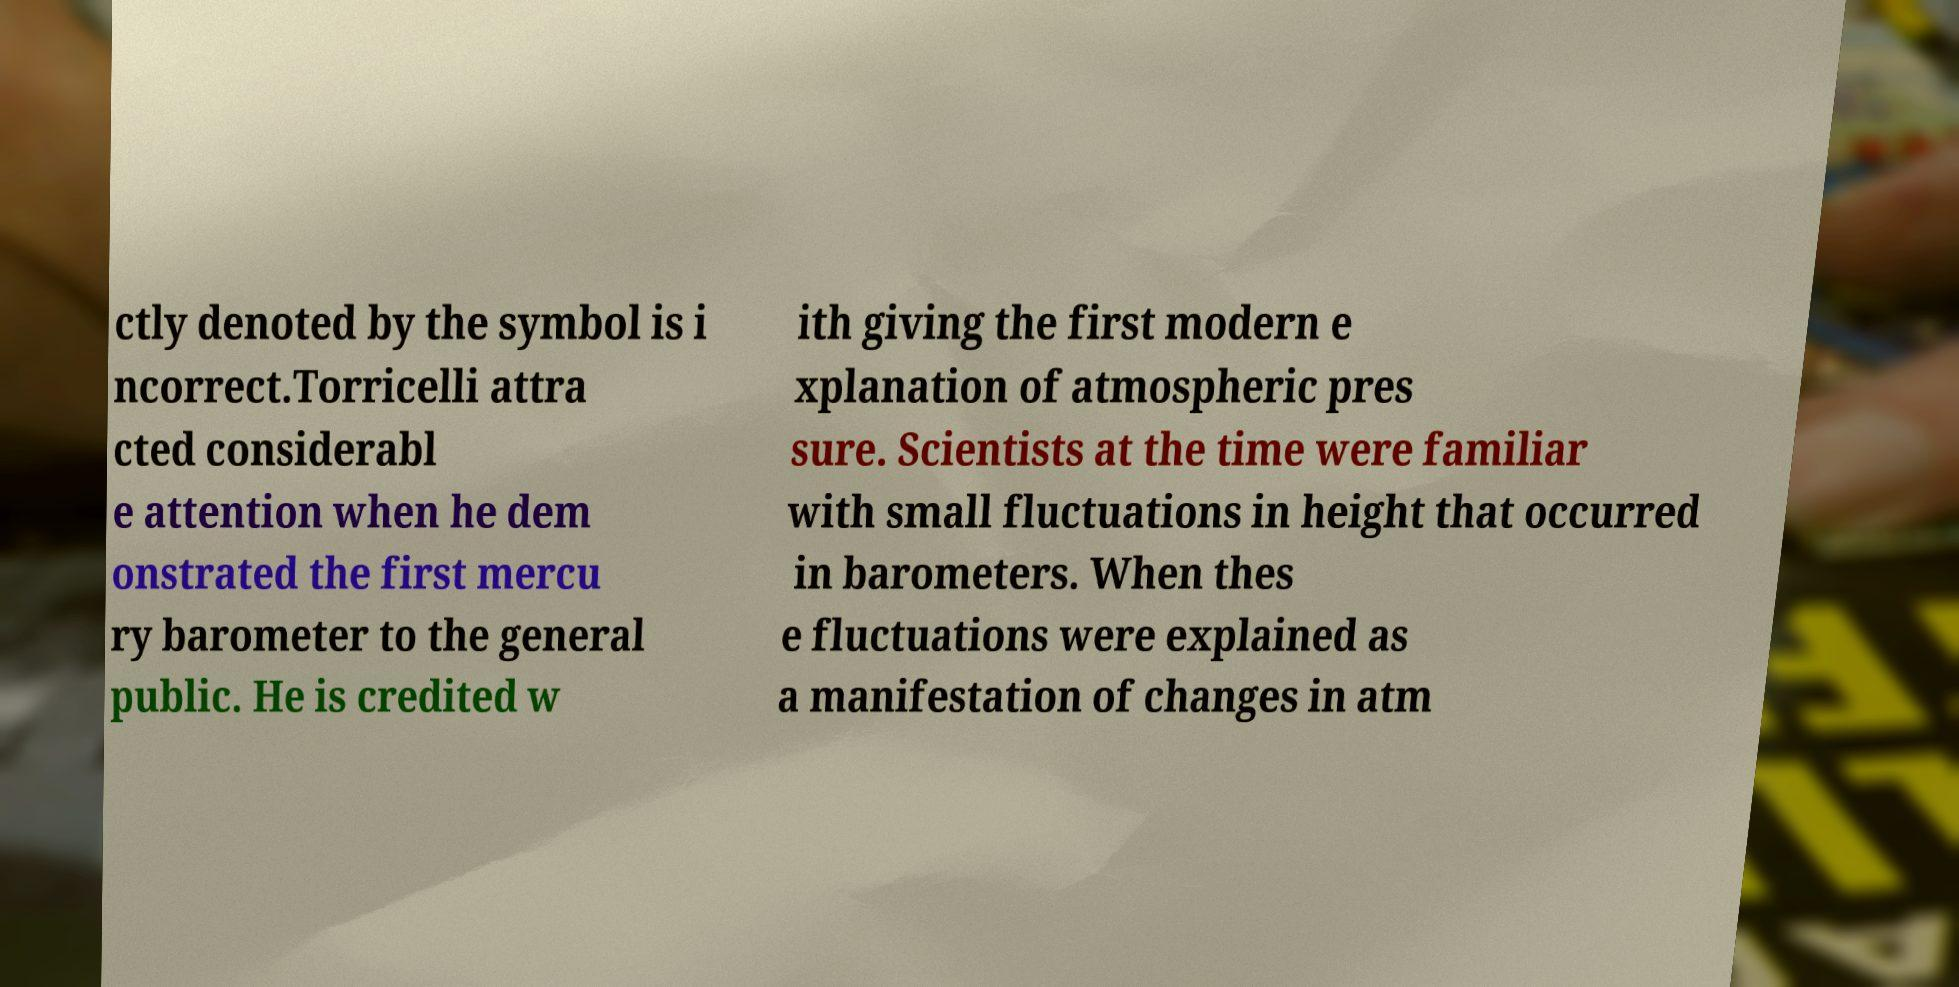I need the written content from this picture converted into text. Can you do that? ctly denoted by the symbol is i ncorrect.Torricelli attra cted considerabl e attention when he dem onstrated the first mercu ry barometer to the general public. He is credited w ith giving the first modern e xplanation of atmospheric pres sure. Scientists at the time were familiar with small fluctuations in height that occurred in barometers. When thes e fluctuations were explained as a manifestation of changes in atm 